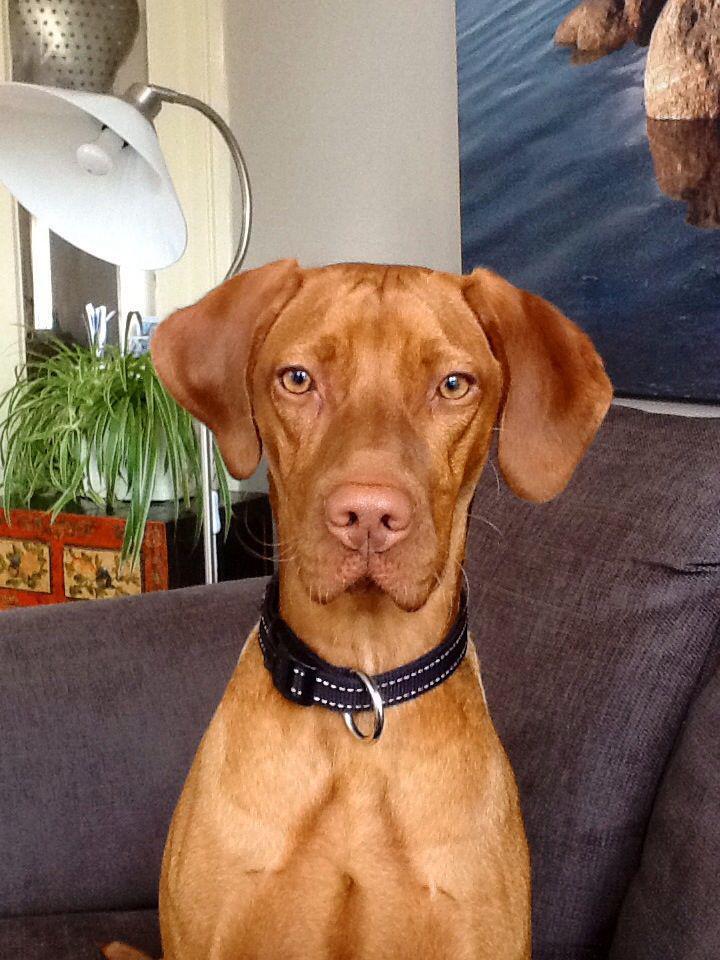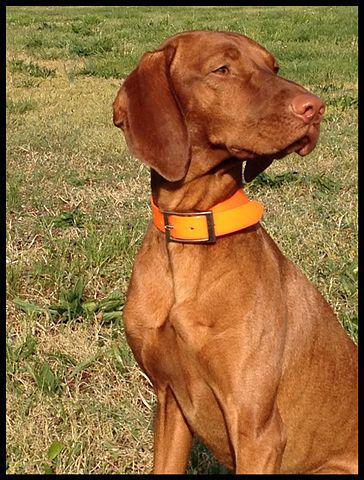The first image is the image on the left, the second image is the image on the right. Analyze the images presented: Is the assertion "One dog is outdoors, while the other dog is indoors." valid? Answer yes or no. Yes. The first image is the image on the left, the second image is the image on the right. Analyze the images presented: Is the assertion "The dog in the right image is wearing a black collar." valid? Answer yes or no. No. 